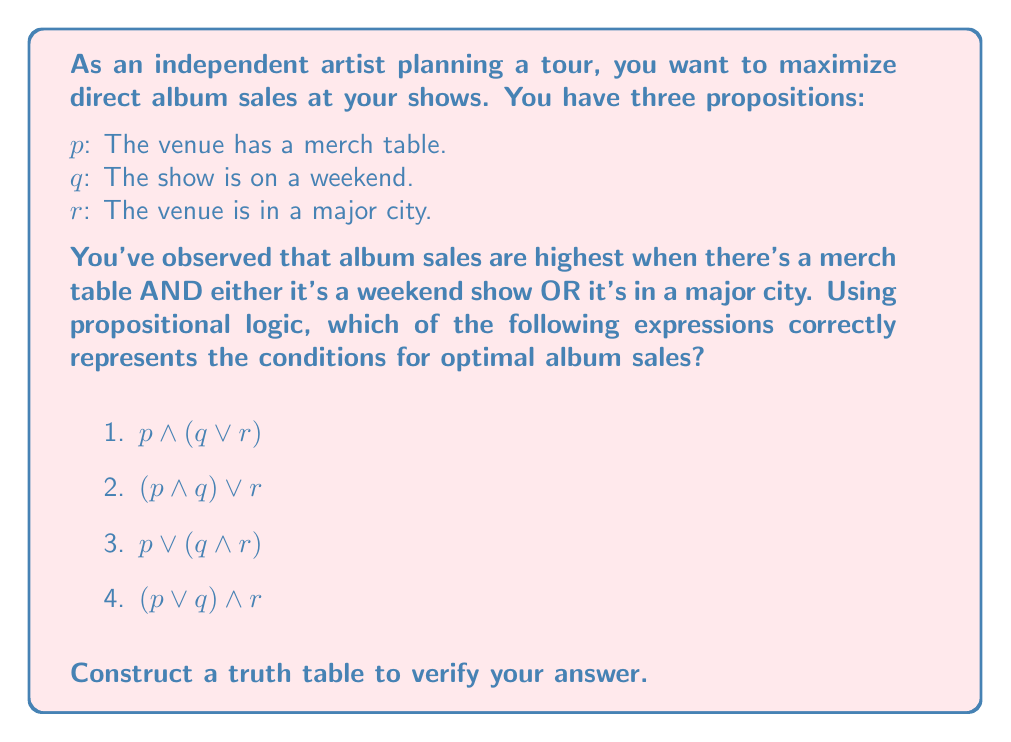Provide a solution to this math problem. Let's approach this step-by-step:

1) First, we need to translate the given condition into a logical expression:
   "Album sales are highest when there's a merch table AND either it's a weekend show OR it's in a major city"
   This translates to: $p \land (q \lor r)$

2) Now, let's construct a truth table for all four options:

   $$\begin{array}{|c|c|c|c|c|c|c|c|}
   \hline
   p & q & r & q \lor r & p \land (q \lor r) & (p \land q) \lor r & p \lor (q \land r) & (p \lor q) \land r \\
   \hline
   T & T & T & T & T & T & T & T \\
   T & T & F & T & T & T & T & F \\
   T & F & T & T & T & T & T & T \\
   T & F & F & F & F & F & T & F \\
   F & T & T & T & F & T & T & T \\
   F & T & F & T & F & F & F & F \\
   F & F & T & T & F & T & T & T \\
   F & F & F & F & F & F & F & F \\
   \hline
   \end{array}$$

3) Analyzing the truth table:
   - Option 1 ($p \land (q \lor r)$) matches our original condition. It's true only when $p$ is true AND either $q$ or $r$ (or both) are true.
   - Option 2 ($\land q) \lor r$) is true more often than our condition allows.
   - Option 3 ($p \lor (q \land r)$) is also true more often than our condition allows.
   - Option 4 ($(p \lor q) \land r$) is true less often than our condition requires.

4) Therefore, option 1 ($p \land (q \lor r)$) is the correct expression for optimal album sales conditions.
Answer: $p \land (q \lor r)$ 